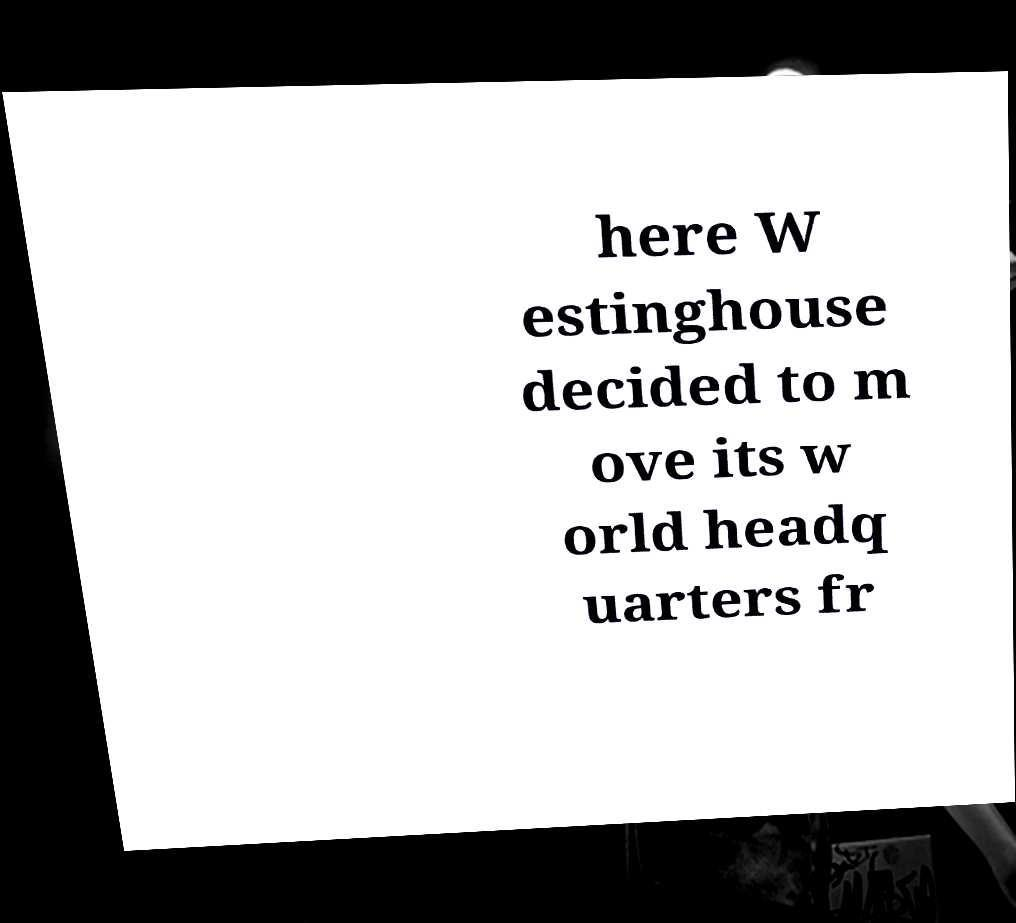Can you read and provide the text displayed in the image?This photo seems to have some interesting text. Can you extract and type it out for me? here W estinghouse decided to m ove its w orld headq uarters fr 